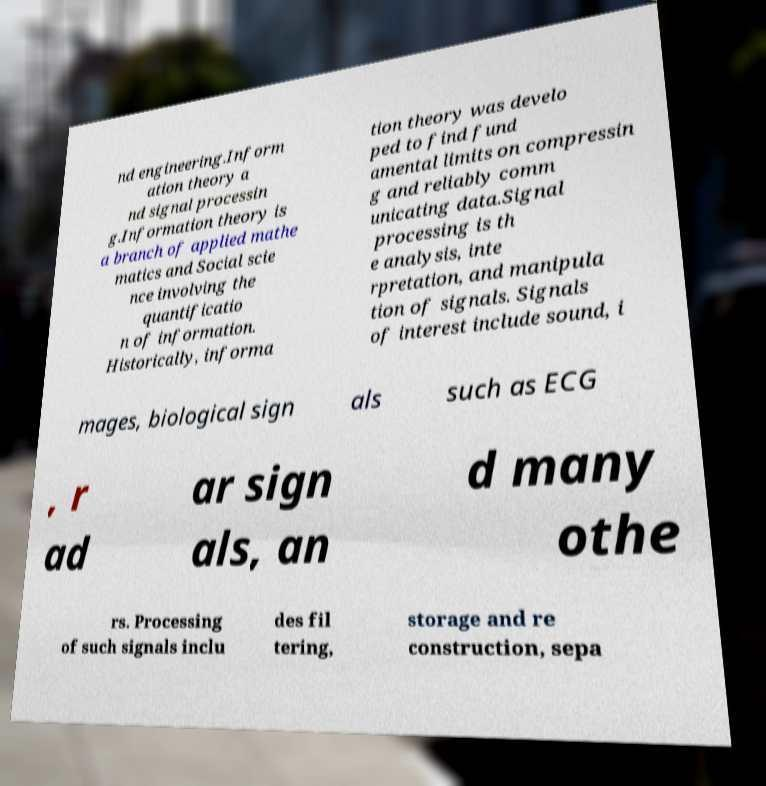For documentation purposes, I need the text within this image transcribed. Could you provide that? nd engineering.Inform ation theory a nd signal processin g.Information theory is a branch of applied mathe matics and Social scie nce involving the quantificatio n of information. Historically, informa tion theory was develo ped to find fund amental limits on compressin g and reliably comm unicating data.Signal processing is th e analysis, inte rpretation, and manipula tion of signals. Signals of interest include sound, i mages, biological sign als such as ECG , r ad ar sign als, an d many othe rs. Processing of such signals inclu des fil tering, storage and re construction, sepa 